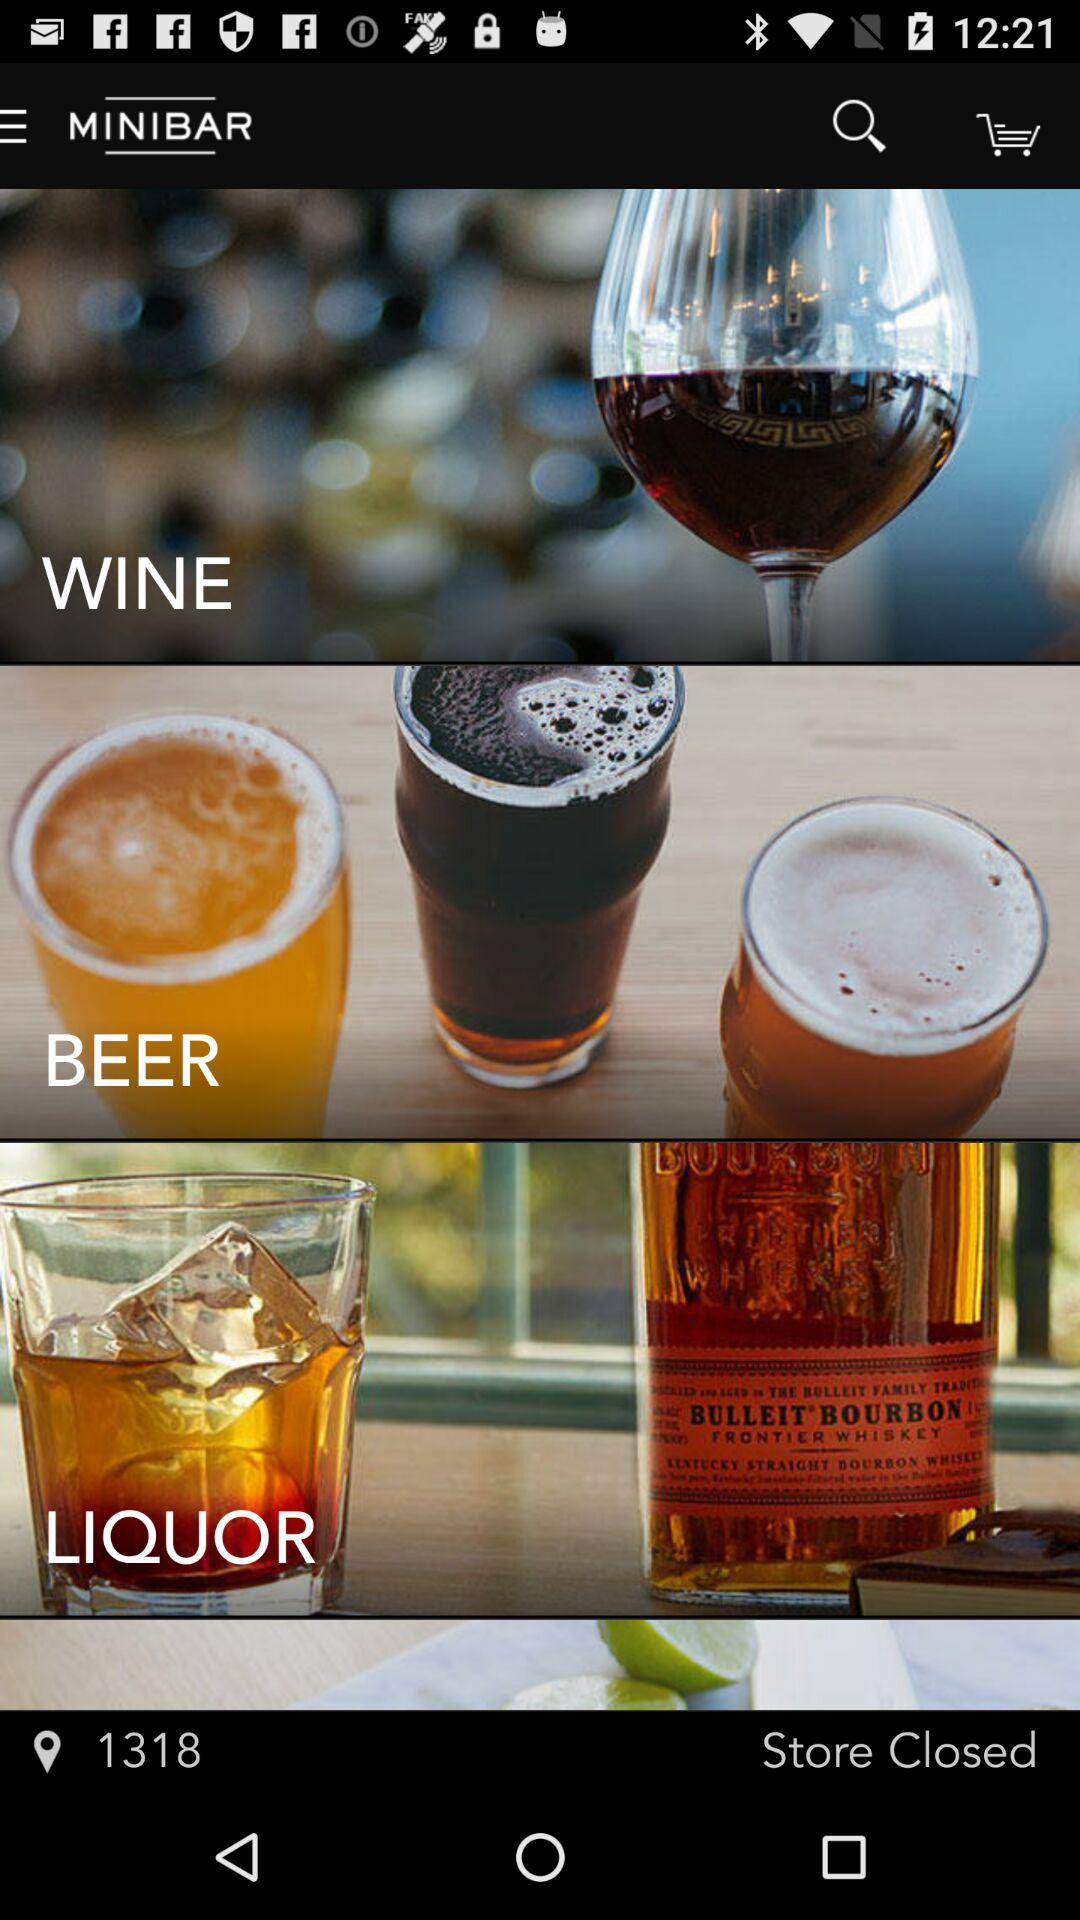How many items have a picture of a glass?
Answer the question using a single word or phrase. 3 